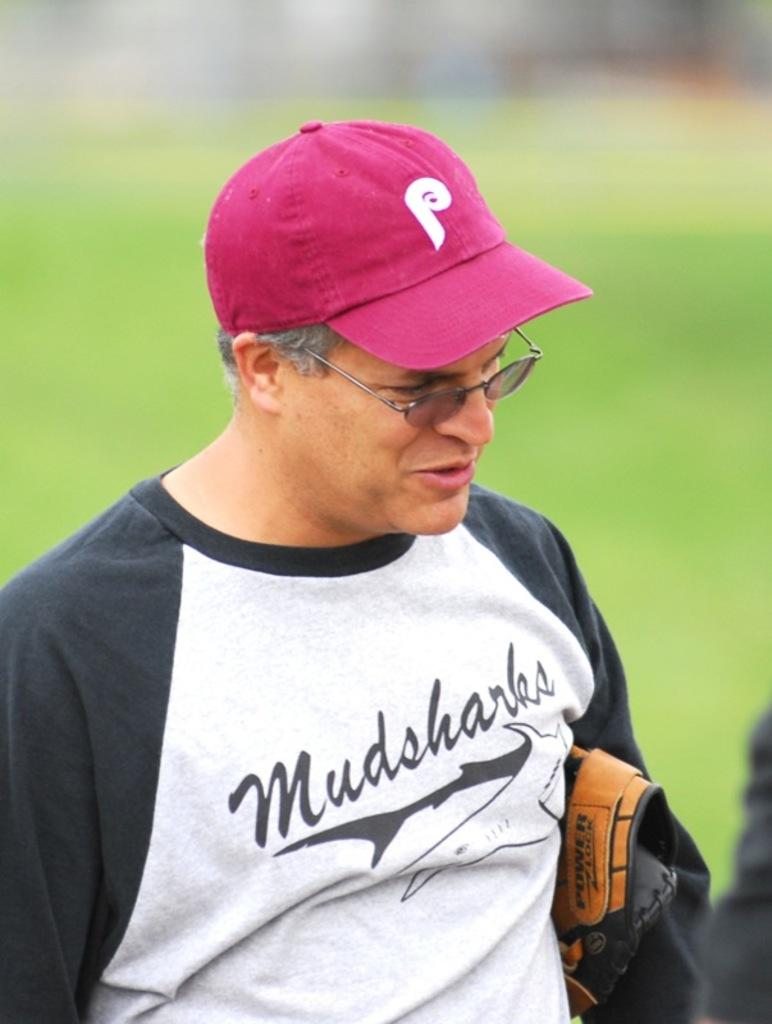<image>
Render a clear and concise summary of the photo. A man is wearing a pink hat with a large letter P in the front 